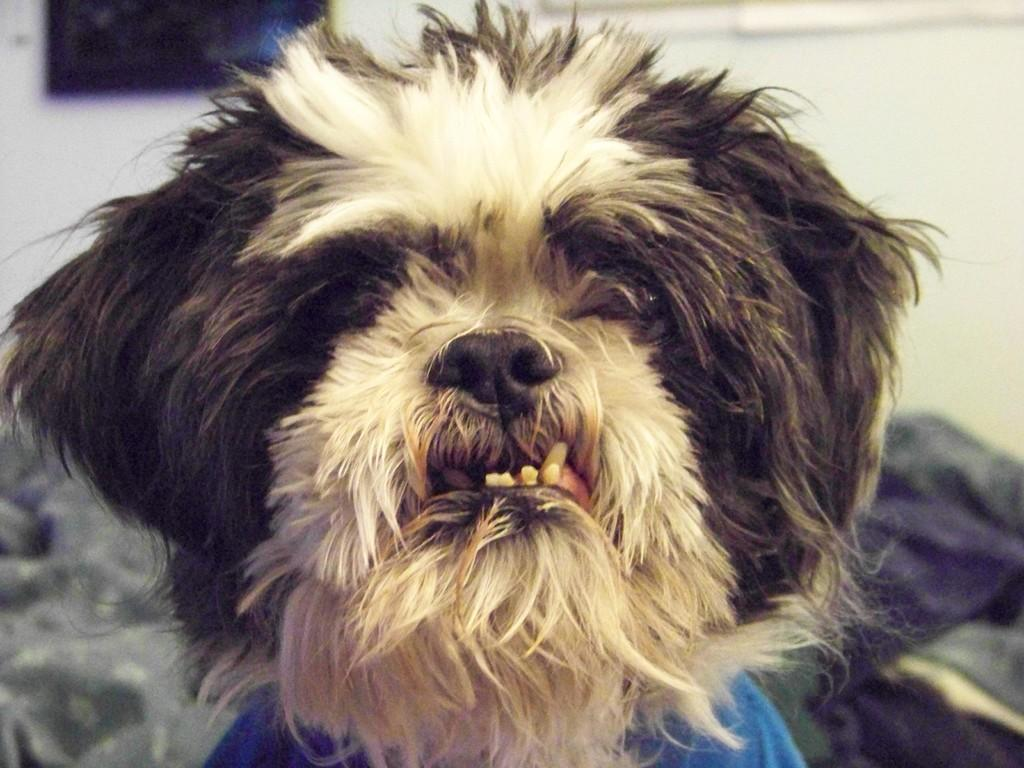What type of animal is in the image? There is a dog in the image. What can be seen in the background of the image? There are clothes and a wall visible in the background of the image. What type of servant is playing with the dog in the image? There is no servant or play activity depicted in the image; it only features a dog and a background with clothes and a wall. 